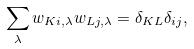<formula> <loc_0><loc_0><loc_500><loc_500>\sum _ { \lambda } w _ { K i , \lambda } w _ { L j , \lambda } = \delta _ { K L } \delta _ { i j } ,</formula> 